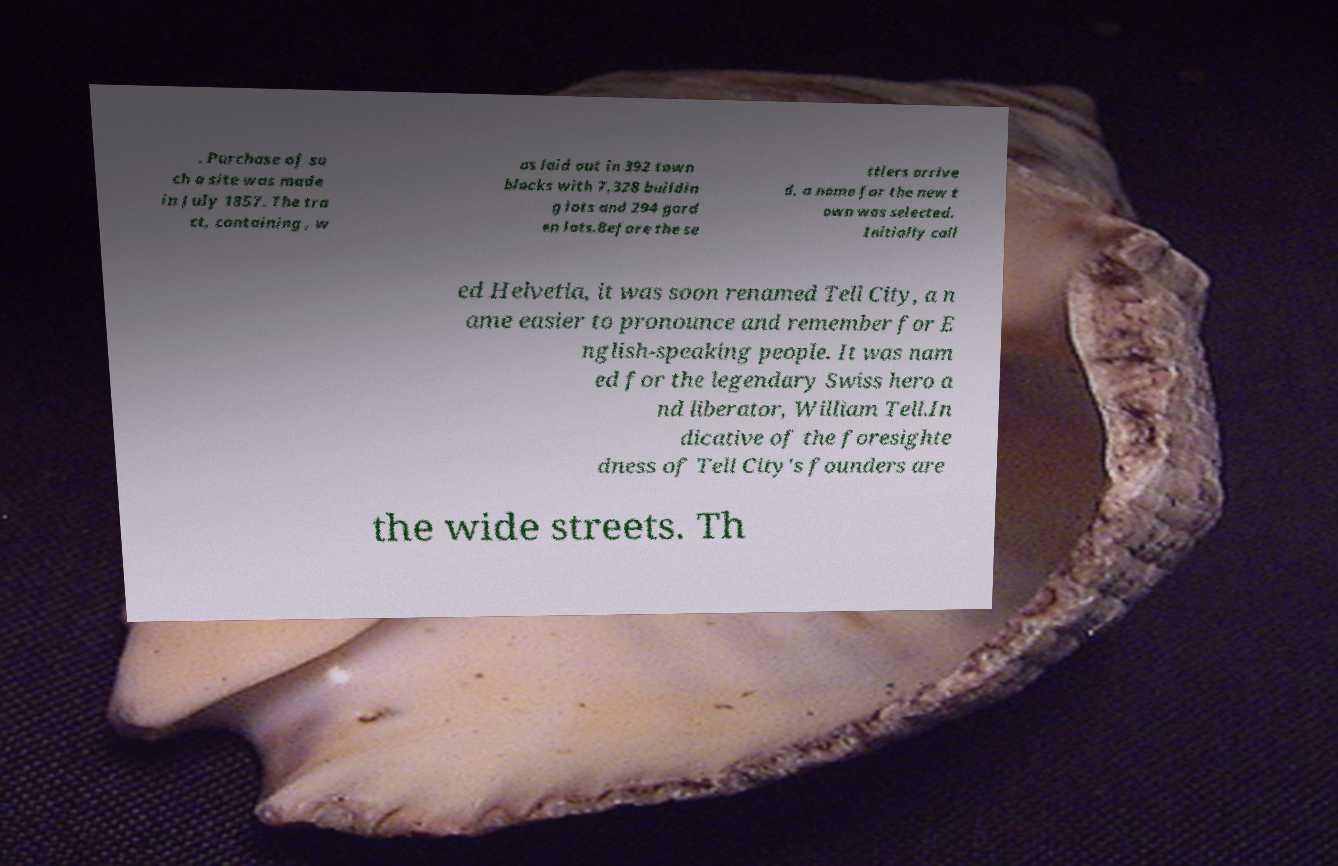Could you extract and type out the text from this image? . Purchase of su ch a site was made in July 1857. The tra ct, containing , w as laid out in 392 town blocks with 7,328 buildin g lots and 294 gard en lots.Before the se ttlers arrive d, a name for the new t own was selected. Initially call ed Helvetia, it was soon renamed Tell City, a n ame easier to pronounce and remember for E nglish-speaking people. It was nam ed for the legendary Swiss hero a nd liberator, William Tell.In dicative of the foresighte dness of Tell City's founders are the wide streets. Th 